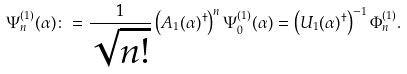Convert formula to latex. <formula><loc_0><loc_0><loc_500><loc_500>\Psi _ { n } ^ { ( 1 ) } ( \alpha ) \colon = \frac { 1 } { \sqrt { n ! } } \left ( A _ { 1 } ( \alpha ) ^ { \dagger } \right ) ^ { n } \Psi _ { 0 } ^ { ( 1 ) } ( \alpha ) = \left ( U _ { 1 } ( \alpha ) ^ { \dagger } \right ) ^ { - 1 } \Phi _ { n } ^ { ( 1 ) } .</formula> 